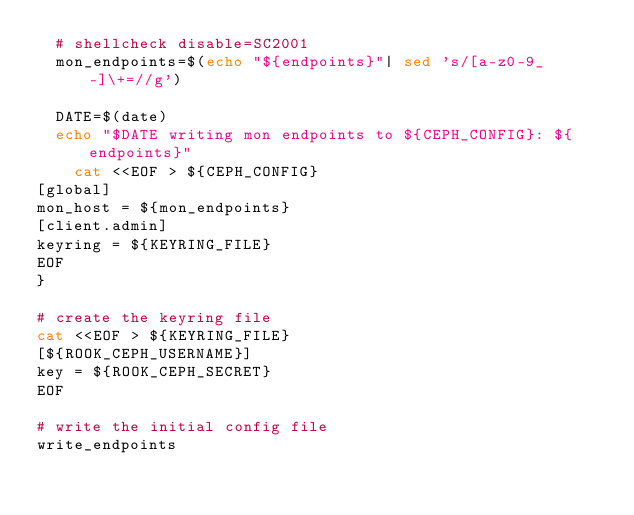Convert code to text. <code><loc_0><loc_0><loc_500><loc_500><_Bash_>  # shellcheck disable=SC2001
  mon_endpoints=$(echo "${endpoints}"| sed 's/[a-z0-9_-]\+=//g')

  DATE=$(date)
  echo "$DATE writing mon endpoints to ${CEPH_CONFIG}: ${endpoints}"
    cat <<EOF > ${CEPH_CONFIG}
[global]
mon_host = ${mon_endpoints}
[client.admin]
keyring = ${KEYRING_FILE}
EOF
}

# create the keyring file
cat <<EOF > ${KEYRING_FILE}
[${ROOK_CEPH_USERNAME}]
key = ${ROOK_CEPH_SECRET}
EOF

# write the initial config file
write_endpoints</code> 